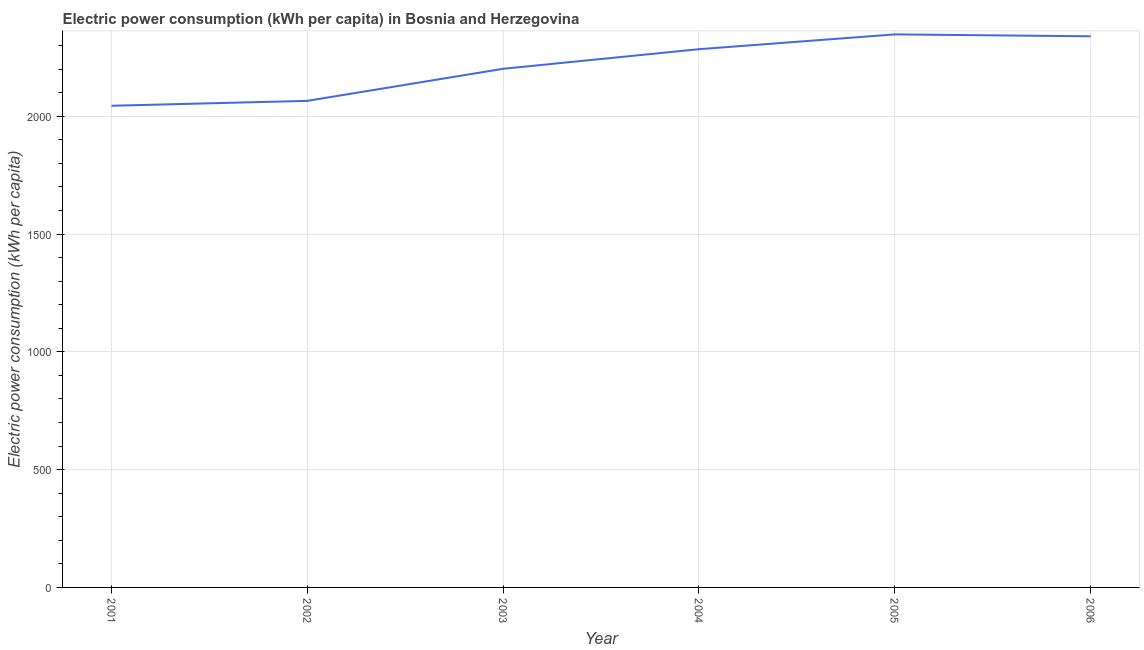What is the electric power consumption in 2002?
Give a very brief answer. 2065.2. Across all years, what is the maximum electric power consumption?
Make the answer very short. 2347.28. Across all years, what is the minimum electric power consumption?
Give a very brief answer. 2044.35. What is the sum of the electric power consumption?
Make the answer very short. 1.33e+04. What is the difference between the electric power consumption in 2001 and 2002?
Give a very brief answer. -20.85. What is the average electric power consumption per year?
Your answer should be compact. 2213.63. What is the median electric power consumption?
Your response must be concise. 2242.87. In how many years, is the electric power consumption greater than 1500 kWh per capita?
Your answer should be very brief. 6. What is the ratio of the electric power consumption in 2003 to that in 2005?
Offer a very short reply. 0.94. Is the electric power consumption in 2003 less than that in 2006?
Keep it short and to the point. Yes. What is the difference between the highest and the second highest electric power consumption?
Give a very brief answer. 8.09. What is the difference between the highest and the lowest electric power consumption?
Provide a short and direct response. 302.93. How many lines are there?
Provide a short and direct response. 1. What is the difference between two consecutive major ticks on the Y-axis?
Give a very brief answer. 500. Are the values on the major ticks of Y-axis written in scientific E-notation?
Your answer should be compact. No. Does the graph contain grids?
Make the answer very short. Yes. What is the title of the graph?
Offer a very short reply. Electric power consumption (kWh per capita) in Bosnia and Herzegovina. What is the label or title of the Y-axis?
Provide a short and direct response. Electric power consumption (kWh per capita). What is the Electric power consumption (kWh per capita) of 2001?
Your answer should be very brief. 2044.35. What is the Electric power consumption (kWh per capita) of 2002?
Keep it short and to the point. 2065.2. What is the Electric power consumption (kWh per capita) of 2003?
Keep it short and to the point. 2201.29. What is the Electric power consumption (kWh per capita) of 2004?
Your answer should be compact. 2284.45. What is the Electric power consumption (kWh per capita) in 2005?
Ensure brevity in your answer.  2347.28. What is the Electric power consumption (kWh per capita) of 2006?
Your answer should be compact. 2339.19. What is the difference between the Electric power consumption (kWh per capita) in 2001 and 2002?
Give a very brief answer. -20.85. What is the difference between the Electric power consumption (kWh per capita) in 2001 and 2003?
Keep it short and to the point. -156.94. What is the difference between the Electric power consumption (kWh per capita) in 2001 and 2004?
Provide a succinct answer. -240.1. What is the difference between the Electric power consumption (kWh per capita) in 2001 and 2005?
Provide a short and direct response. -302.93. What is the difference between the Electric power consumption (kWh per capita) in 2001 and 2006?
Your answer should be very brief. -294.85. What is the difference between the Electric power consumption (kWh per capita) in 2002 and 2003?
Make the answer very short. -136.09. What is the difference between the Electric power consumption (kWh per capita) in 2002 and 2004?
Provide a succinct answer. -219.25. What is the difference between the Electric power consumption (kWh per capita) in 2002 and 2005?
Your response must be concise. -282.08. What is the difference between the Electric power consumption (kWh per capita) in 2002 and 2006?
Your response must be concise. -273.99. What is the difference between the Electric power consumption (kWh per capita) in 2003 and 2004?
Offer a very short reply. -83.16. What is the difference between the Electric power consumption (kWh per capita) in 2003 and 2005?
Offer a very short reply. -145.99. What is the difference between the Electric power consumption (kWh per capita) in 2003 and 2006?
Keep it short and to the point. -137.91. What is the difference between the Electric power consumption (kWh per capita) in 2004 and 2005?
Provide a succinct answer. -62.83. What is the difference between the Electric power consumption (kWh per capita) in 2004 and 2006?
Your answer should be very brief. -54.75. What is the difference between the Electric power consumption (kWh per capita) in 2005 and 2006?
Offer a terse response. 8.09. What is the ratio of the Electric power consumption (kWh per capita) in 2001 to that in 2002?
Offer a terse response. 0.99. What is the ratio of the Electric power consumption (kWh per capita) in 2001 to that in 2003?
Your answer should be compact. 0.93. What is the ratio of the Electric power consumption (kWh per capita) in 2001 to that in 2004?
Your answer should be very brief. 0.9. What is the ratio of the Electric power consumption (kWh per capita) in 2001 to that in 2005?
Offer a very short reply. 0.87. What is the ratio of the Electric power consumption (kWh per capita) in 2001 to that in 2006?
Give a very brief answer. 0.87. What is the ratio of the Electric power consumption (kWh per capita) in 2002 to that in 2003?
Your answer should be very brief. 0.94. What is the ratio of the Electric power consumption (kWh per capita) in 2002 to that in 2004?
Your answer should be very brief. 0.9. What is the ratio of the Electric power consumption (kWh per capita) in 2002 to that in 2006?
Your answer should be compact. 0.88. What is the ratio of the Electric power consumption (kWh per capita) in 2003 to that in 2004?
Offer a very short reply. 0.96. What is the ratio of the Electric power consumption (kWh per capita) in 2003 to that in 2005?
Ensure brevity in your answer.  0.94. What is the ratio of the Electric power consumption (kWh per capita) in 2003 to that in 2006?
Make the answer very short. 0.94. 